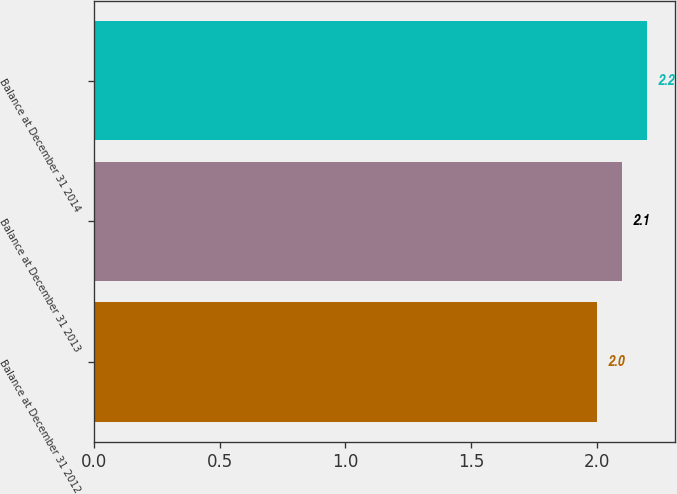Convert chart to OTSL. <chart><loc_0><loc_0><loc_500><loc_500><bar_chart><fcel>Balance at December 31 2012<fcel>Balance at December 31 2013<fcel>Balance at December 31 2014<nl><fcel>2<fcel>2.1<fcel>2.2<nl></chart> 